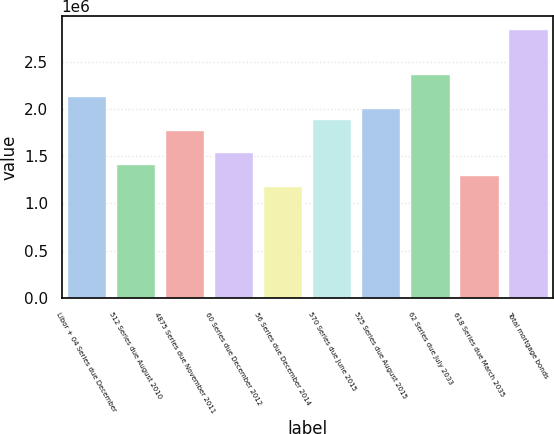Convert chart. <chart><loc_0><loc_0><loc_500><loc_500><bar_chart><fcel>Libor + 04 Series due December<fcel>512 Series due August 2010<fcel>4875 Series due November 2011<fcel>60 Series due December 2012<fcel>56 Series due December 2014<fcel>570 Series due June 2015<fcel>525 Series due August 2015<fcel>62 Series due July 2033<fcel>618 Series due March 2035<fcel>Total mortgage bonds<nl><fcel>2.13202e+06<fcel>1.42166e+06<fcel>1.77684e+06<fcel>1.54005e+06<fcel>1.18488e+06<fcel>1.89523e+06<fcel>2.01362e+06<fcel>2.3688e+06<fcel>1.30327e+06<fcel>2.84237e+06<nl></chart> 